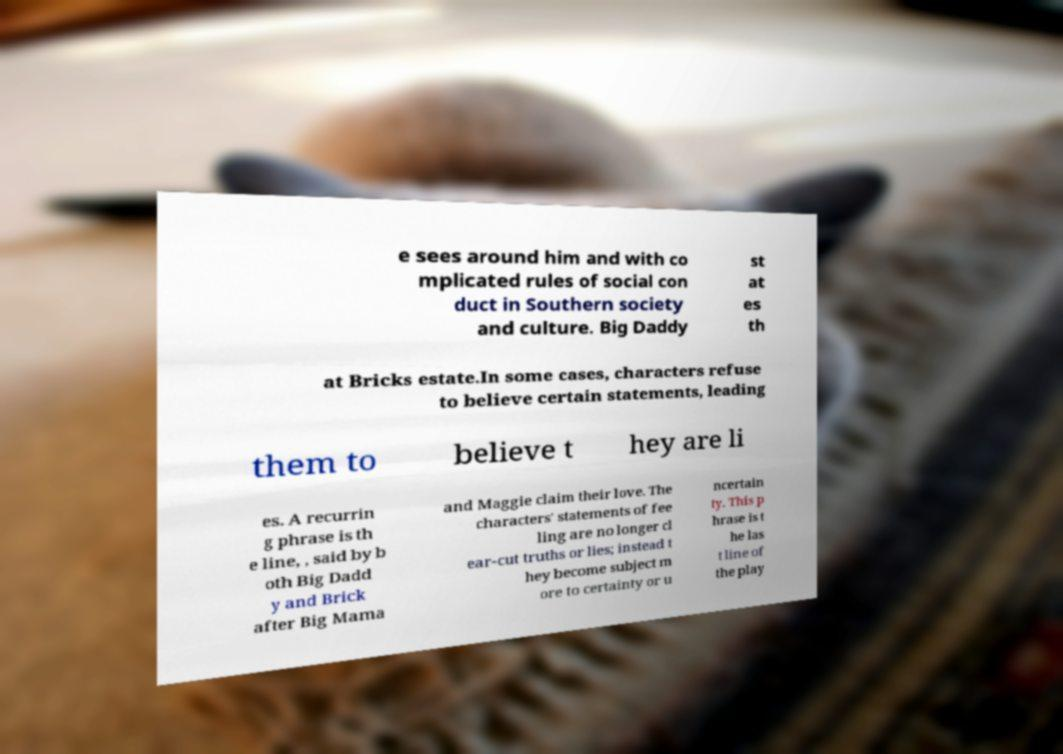I need the written content from this picture converted into text. Can you do that? e sees around him and with co mplicated rules of social con duct in Southern society and culture. Big Daddy st at es th at Bricks estate.In some cases, characters refuse to believe certain statements, leading them to believe t hey are li es. A recurrin g phrase is th e line, , said by b oth Big Dadd y and Brick after Big Mama and Maggie claim their love. The characters' statements of fee ling are no longer cl ear-cut truths or lies; instead t hey become subject m ore to certainty or u ncertain ty. This p hrase is t he las t line of the play 